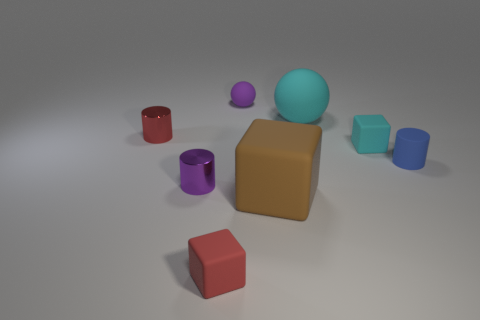Add 1 large purple matte balls. How many objects exist? 9 Subtract all cylinders. How many objects are left? 5 Add 2 large cyan objects. How many large cyan objects exist? 3 Subtract 0 green balls. How many objects are left? 8 Subtract all small red objects. Subtract all small purple rubber spheres. How many objects are left? 5 Add 8 small blocks. How many small blocks are left? 10 